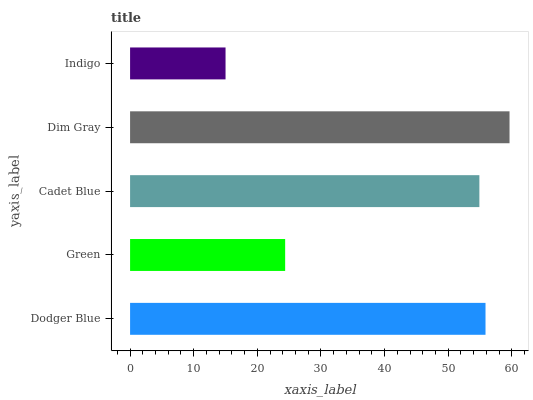Is Indigo the minimum?
Answer yes or no. Yes. Is Dim Gray the maximum?
Answer yes or no. Yes. Is Green the minimum?
Answer yes or no. No. Is Green the maximum?
Answer yes or no. No. Is Dodger Blue greater than Green?
Answer yes or no. Yes. Is Green less than Dodger Blue?
Answer yes or no. Yes. Is Green greater than Dodger Blue?
Answer yes or no. No. Is Dodger Blue less than Green?
Answer yes or no. No. Is Cadet Blue the high median?
Answer yes or no. Yes. Is Cadet Blue the low median?
Answer yes or no. Yes. Is Indigo the high median?
Answer yes or no. No. Is Dodger Blue the low median?
Answer yes or no. No. 